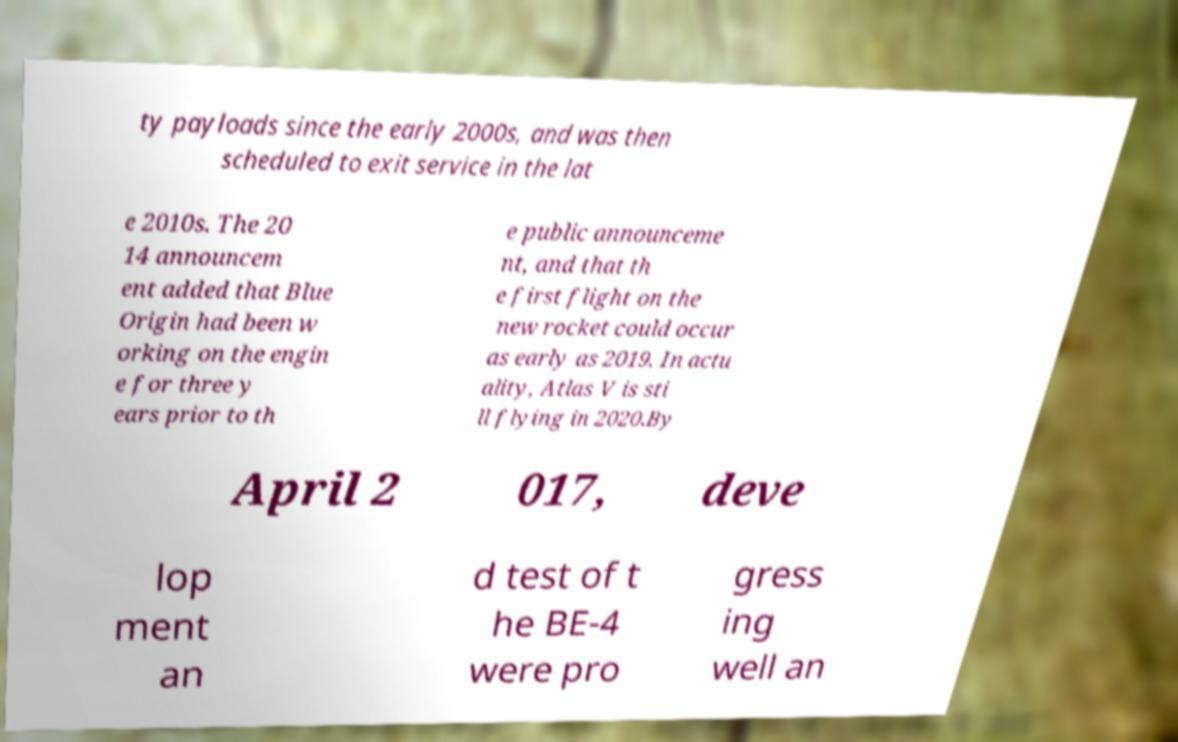For documentation purposes, I need the text within this image transcribed. Could you provide that? ty payloads since the early 2000s, and was then scheduled to exit service in the lat e 2010s. The 20 14 announcem ent added that Blue Origin had been w orking on the engin e for three y ears prior to th e public announceme nt, and that th e first flight on the new rocket could occur as early as 2019. In actu ality, Atlas V is sti ll flying in 2020.By April 2 017, deve lop ment an d test of t he BE-4 were pro gress ing well an 